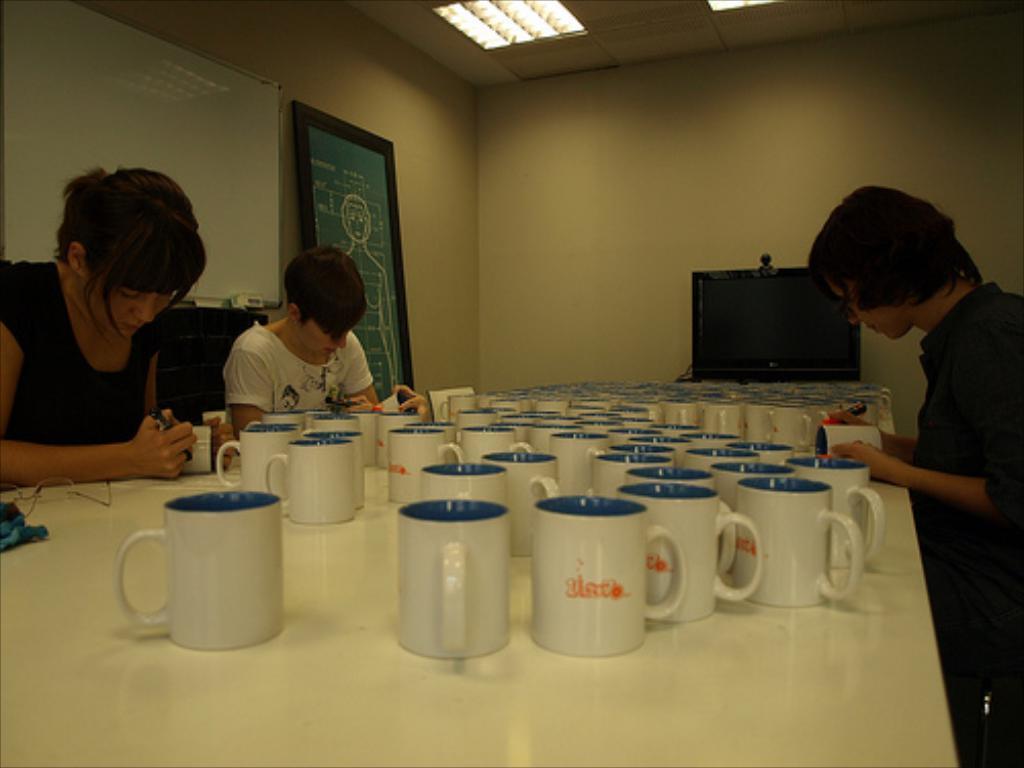How would you summarize this image in a sentence or two? This is an inside view of a room. At the bottom there is a table on which there are many mugs. On the right and left side of the image there are few persons sitting, holding the mugs and some other objects in the hands. It seems like they are writing some text on the mugs. In the background there is a board and a monitor attached to a wall. At the top of the image there are two lights. 